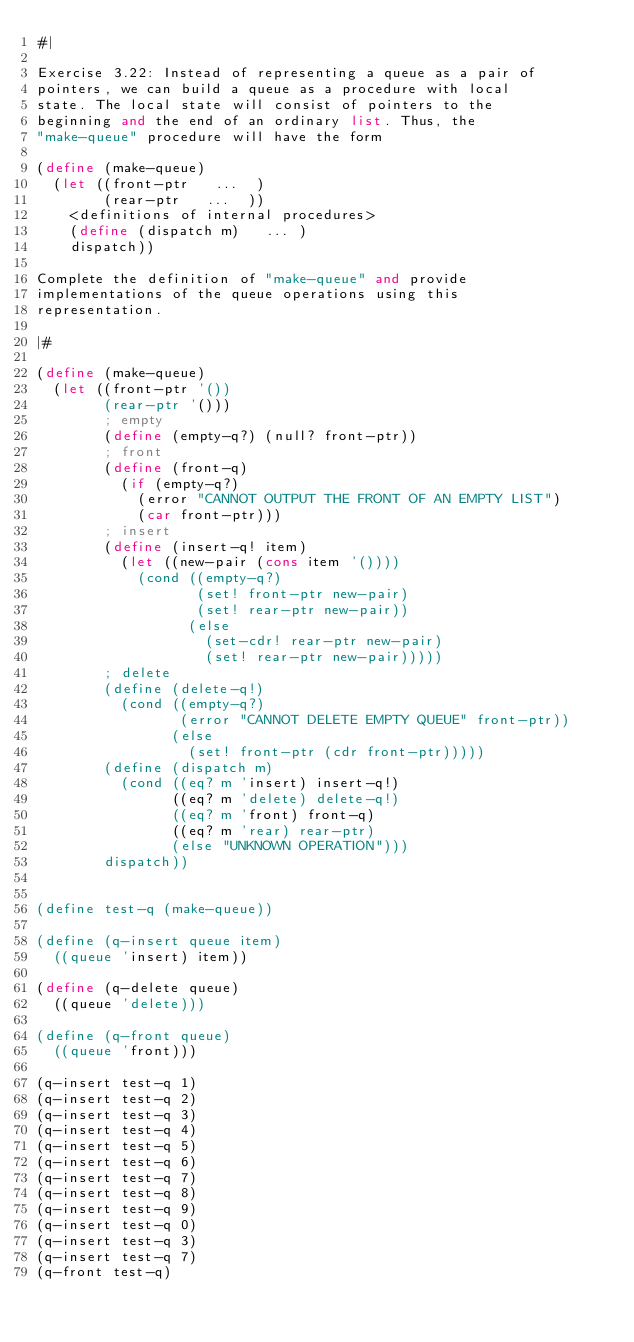<code> <loc_0><loc_0><loc_500><loc_500><_Scheme_>#|

Exercise 3.22: Instead of representing a queue as a pair of
pointers, we can build a queue as a procedure with local
state. The local state will consist of pointers to the
beginning and the end of an ordinary list. Thus, the
"make-queue" procedure will have the form

(define (make-queue)
  (let ((front-ptr   ...  )
        (rear-ptr   ...  ))
    <definitions of internal procedures>
    (define (dispatch m)   ... )
    dispatch))

Complete the definition of "make-queue" and provide
implementations of the queue operations using this
representation.

|#

(define (make-queue)
  (let ((front-ptr '())
        (rear-ptr '()))
        ; empty
        (define (empty-q?) (null? front-ptr))
        ; front
        (define (front-q)
          (if (empty-q?)
            (error "CANNOT OUTPUT THE FRONT OF AN EMPTY LIST")
            (car front-ptr)))
        ; insert
        (define (insert-q! item)
          (let ((new-pair (cons item '())))
            (cond ((empty-q?)
                   (set! front-ptr new-pair)
                   (set! rear-ptr new-pair))
                  (else
                    (set-cdr! rear-ptr new-pair)
                    (set! rear-ptr new-pair)))))
        ; delete
        (define (delete-q!)
          (cond ((empty-q?)
                 (error "CANNOT DELETE EMPTY QUEUE" front-ptr))
                (else 
                  (set! front-ptr (cdr front-ptr)))))
        (define (dispatch m)
          (cond ((eq? m 'insert) insert-q!)
                ((eq? m 'delete) delete-q!)
                ((eq? m 'front) front-q)
                ((eq? m 'rear) rear-ptr)
                (else "UNKNOWN OPERATION")))
        dispatch))


(define test-q (make-queue))

(define (q-insert queue item)
  ((queue 'insert) item))

(define (q-delete queue)
  ((queue 'delete)))

(define (q-front queue)
  ((queue 'front)))

(q-insert test-q 1)
(q-insert test-q 2)
(q-insert test-q 3)
(q-insert test-q 4)
(q-insert test-q 5)
(q-insert test-q 6)
(q-insert test-q 7)
(q-insert test-q 8)
(q-insert test-q 9)
(q-insert test-q 0)
(q-insert test-q 3)
(q-insert test-q 7)
(q-front test-q)

</code> 